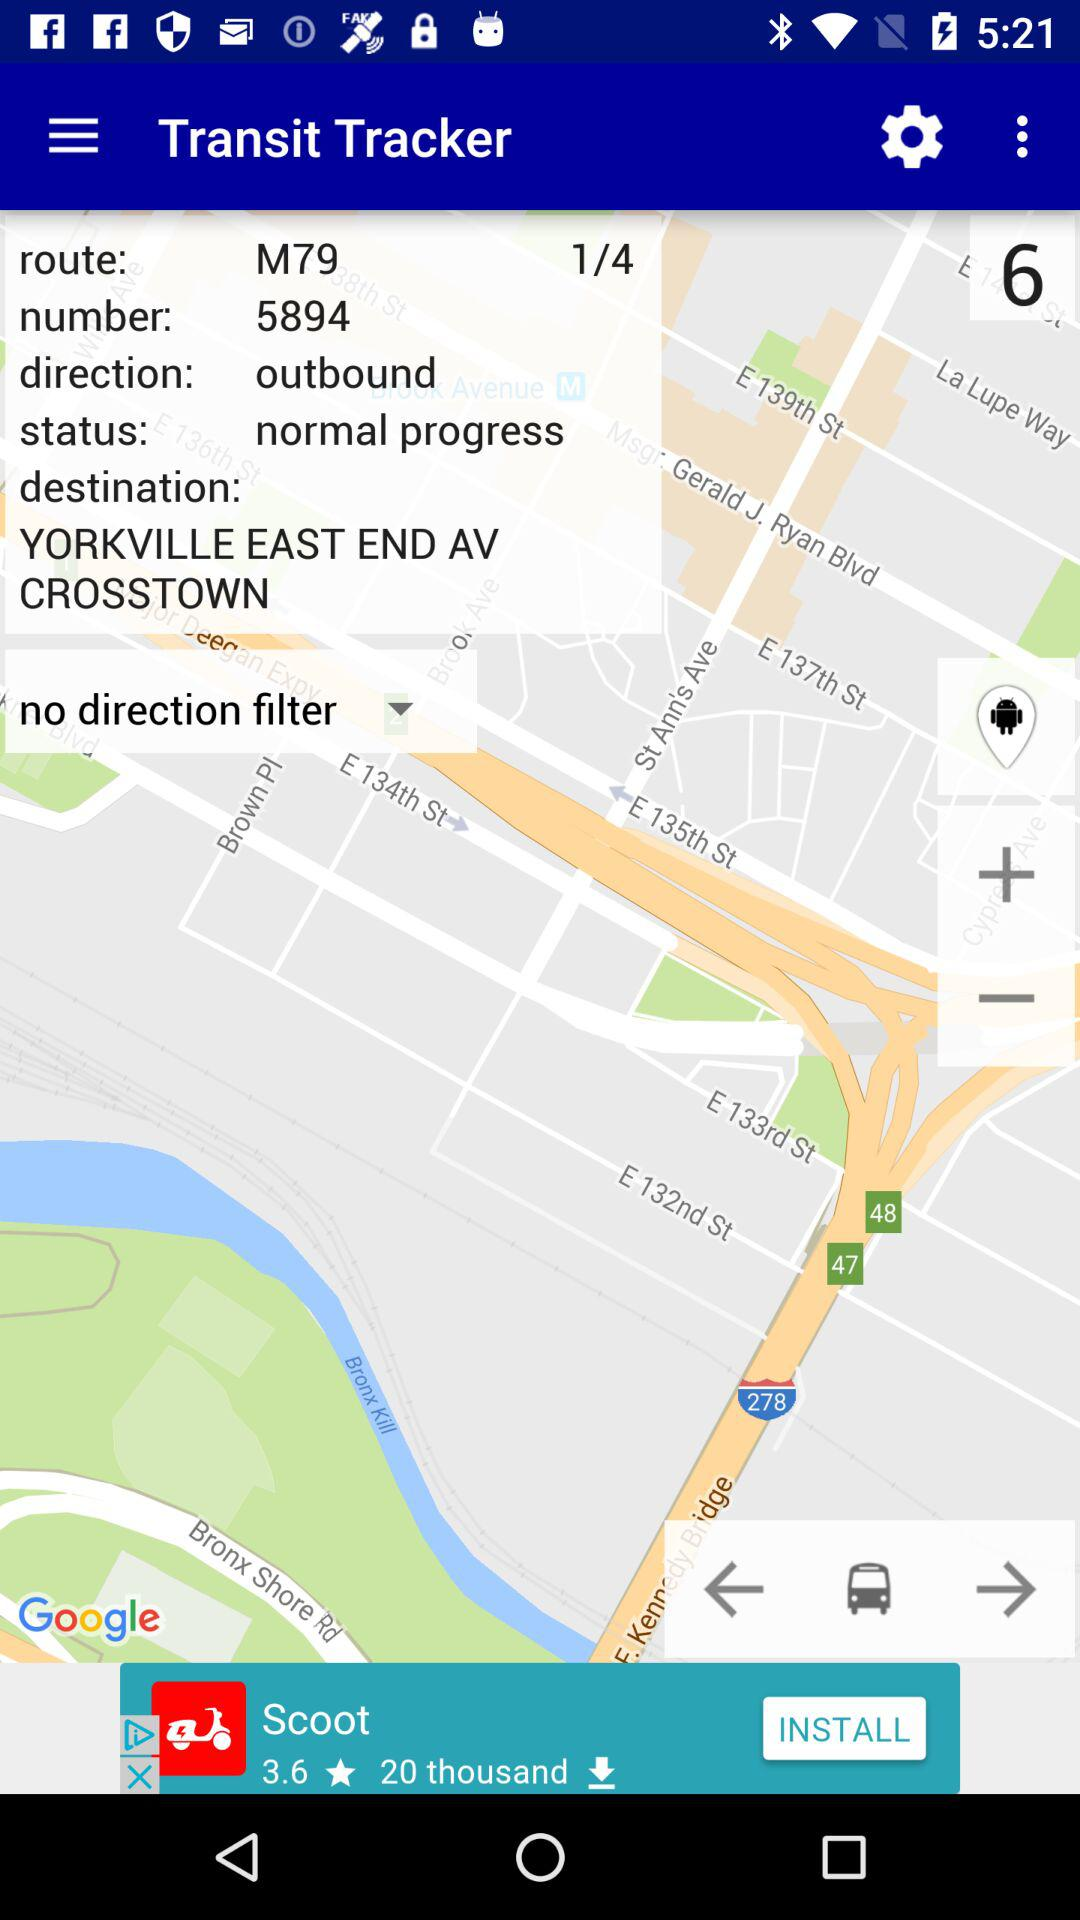What is the route for the location? The route for the location is M79. 